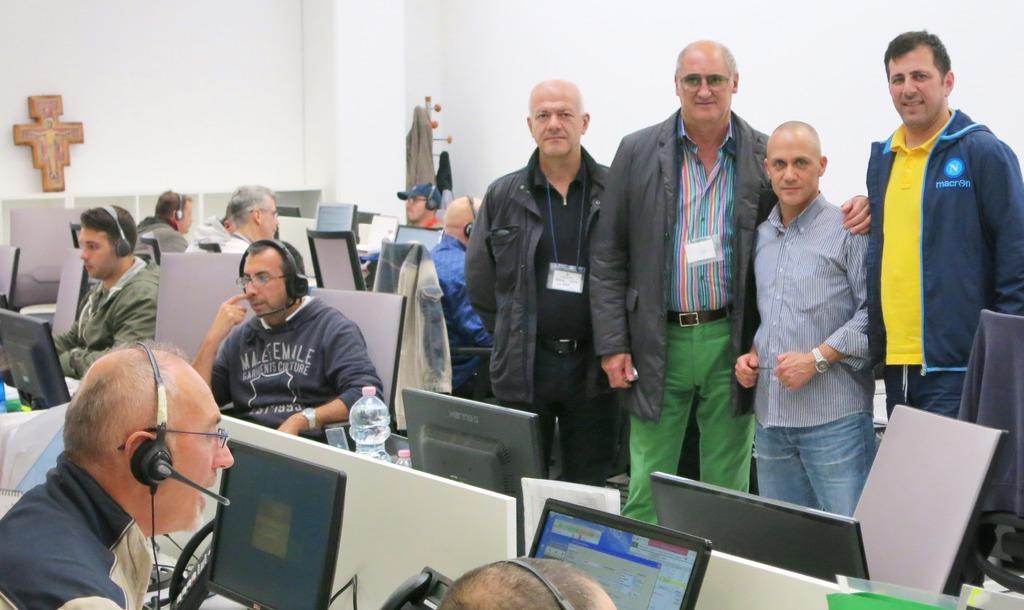In one or two sentences, can you explain what this image depicts? In this image we can see people standing, we can see few people sitting and wearing microphones, we can see the chairs, we can see electronic gadgets on the desk, near that we can see bottles, we can see few objects on the wall in the background. 